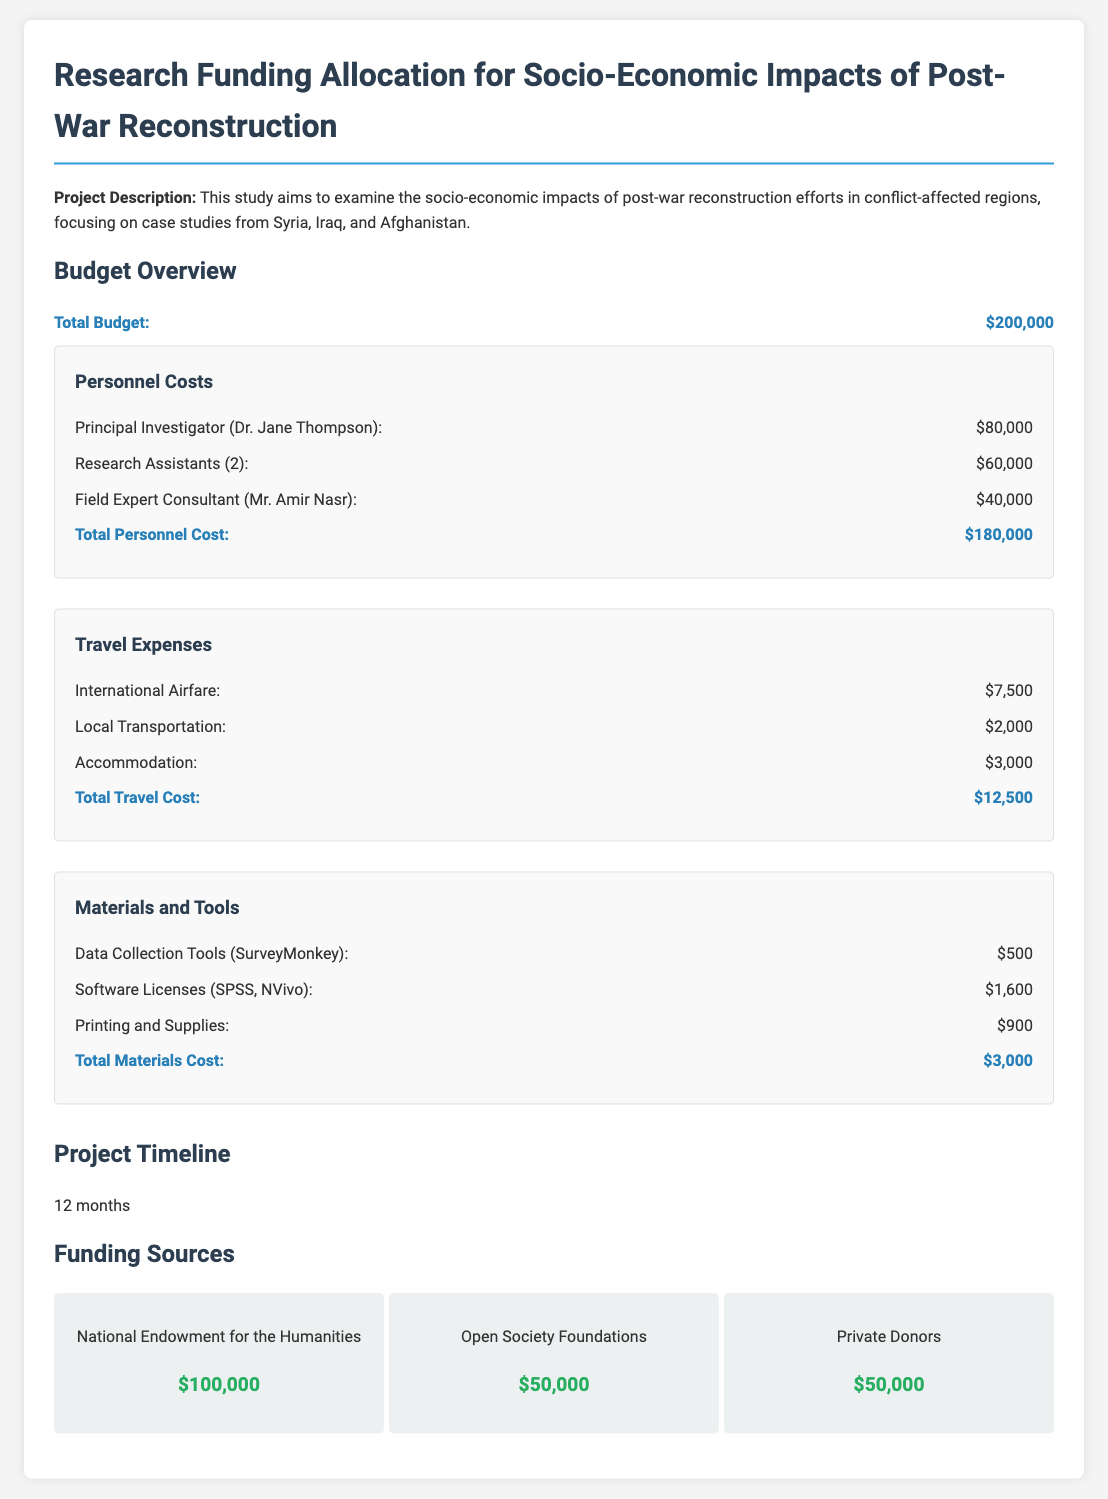What is the total budget? The total budget is stated clearly in the document as $200,000.
Answer: $200,000 Who is the Principal Investigator? The document names Dr. Jane Thompson as the Principal Investigator.
Answer: Dr. Jane Thompson How much are the Research Assistants being paid? The budget specifies the total payment for two Research Assistants as $60,000.
Answer: $60,000 What is the total travel cost? The document summarizes all travel expenses to total $12,500.
Answer: $12,500 How long is the project timeline? The project timeline indicates that it will last for 12 months.
Answer: 12 months What is the funding amount from the National Endowment for the Humanities? The document states that the funding from this source is $100,000.
Answer: $100,000 How much is allocated for printing and supplies? The budget allocates $900 specifically for printing and supplies.
Answer: $900 Which software licenses are included in the materials cost? The materials section lists SPSS and NVivo as the included software licenses.
Answer: SPSS, NVivo What is the total personnel cost? The total personnel cost is the sum of all personnel expenses, which amounts to $180,000.
Answer: $180,000 